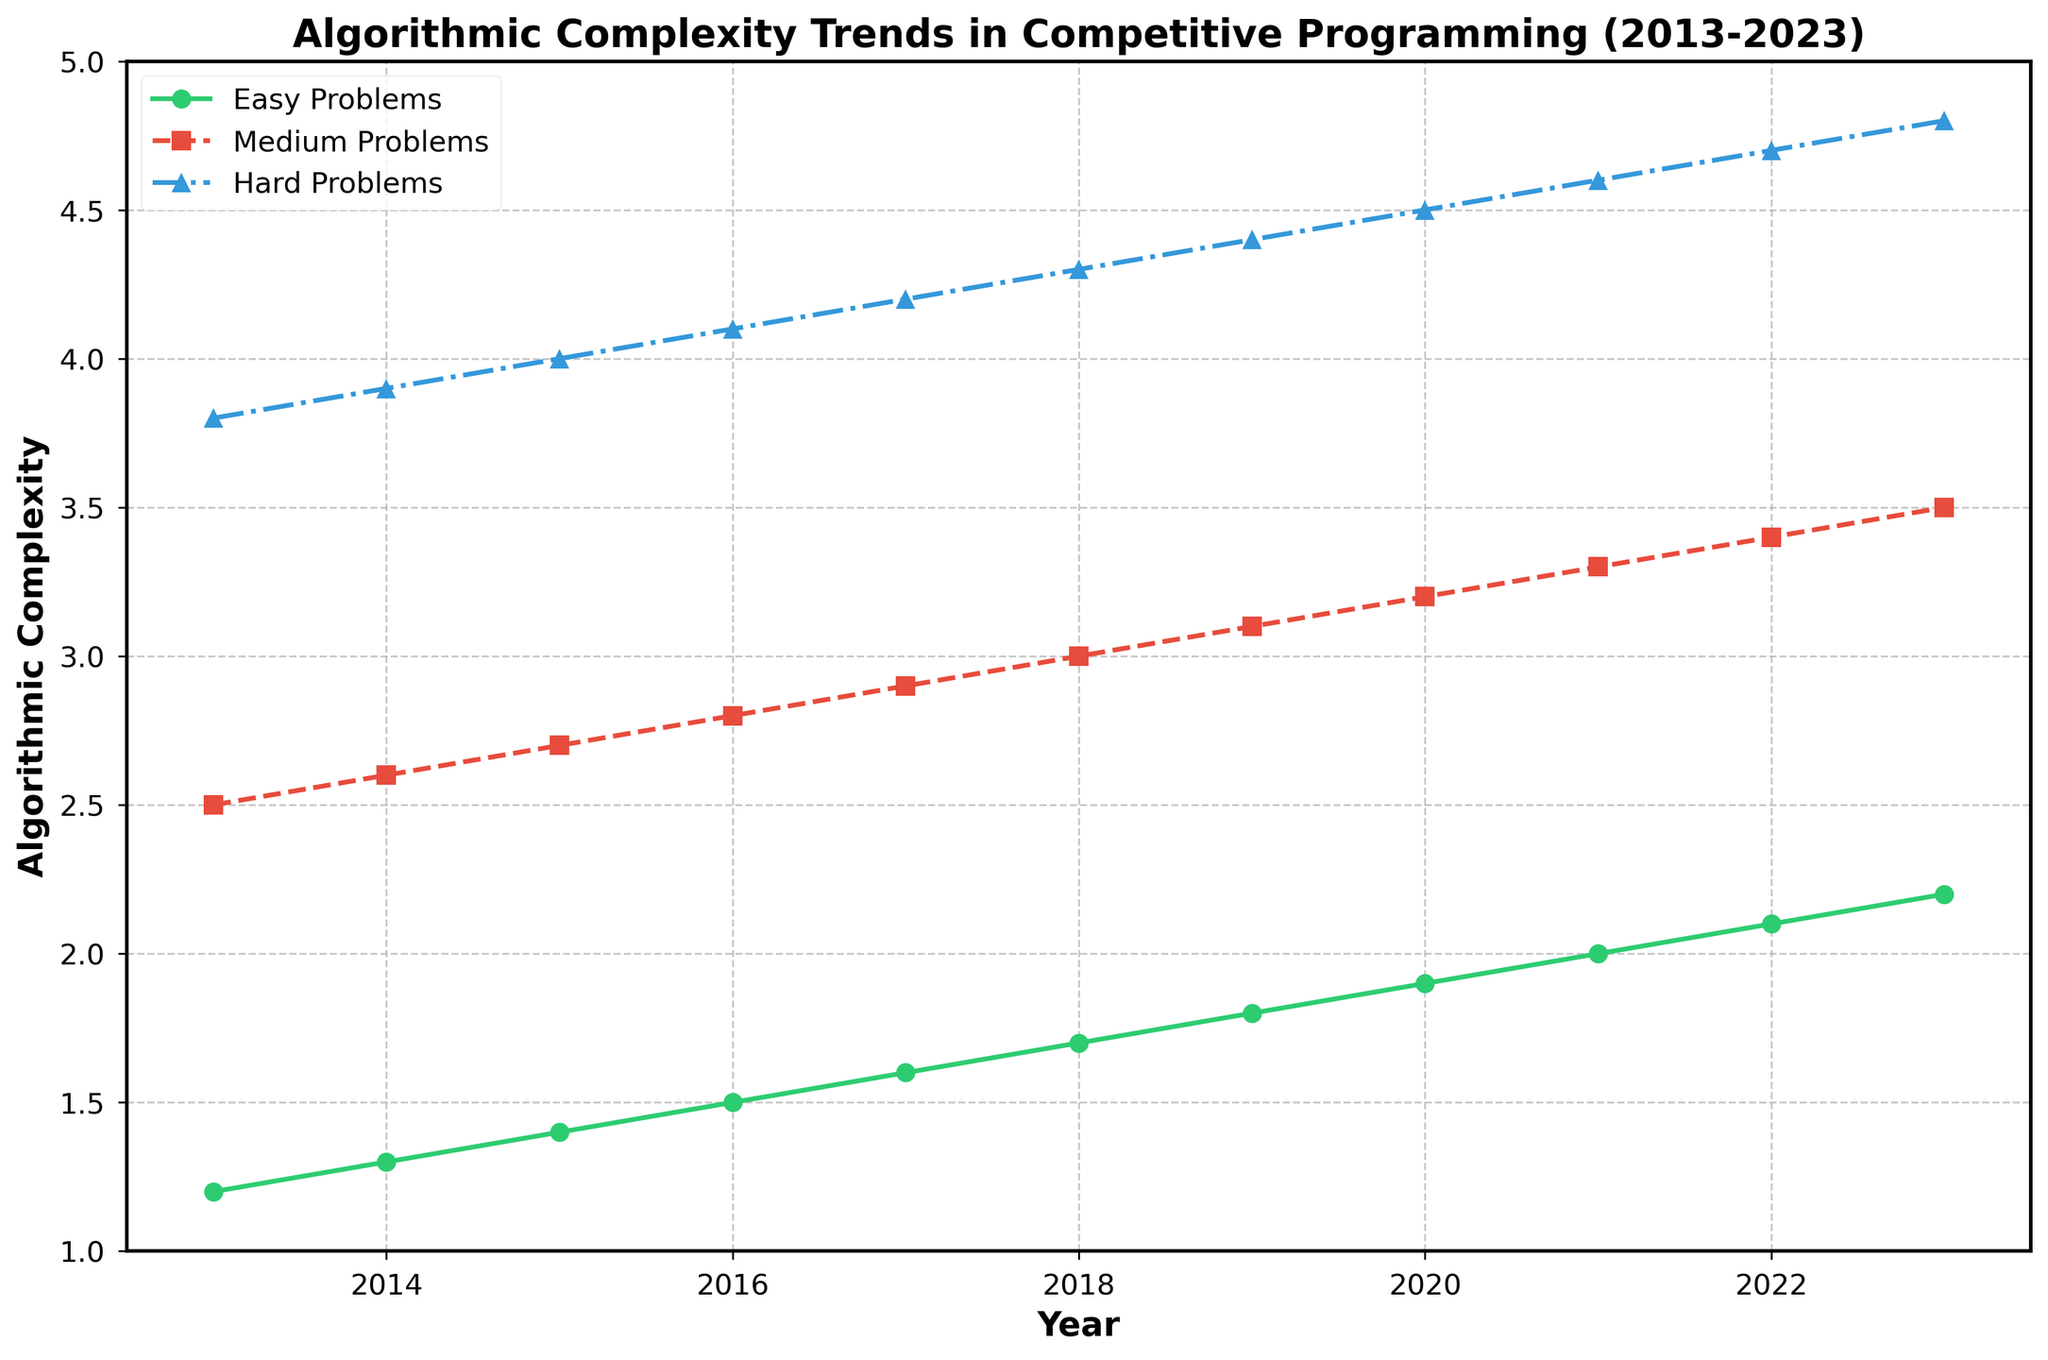What year did the algorithmic complexity for Easy Problems reach 2.0? According to the chart, the algorithmic complexity for Easy Problems reached 2.0 in the year where the green line crosses the 2.0 mark on the y-axis. This occurred in 2021.
Answer: 2021 During which year did the algorithmic complexity for Hard Problems surpass 4.0? The blue line representing Hard Problems surpasses the 4.0 mark on the y-axis when it crosses above this value. This first occurs between 2016 and 2017, specifically in 2017.
Answer: 2017 How much did the algorithmic complexity of Medium Problems increase from 2013 to 2023? From the chart, the complexity for Medium Problems (depicted by the red line) in 2013 is 2.5, and in 2023 it's 3.5. The increase is calculated as 3.5 - 2.5 = 1.0.
Answer: 1.0 Which category of problems showed the most significant increase in algorithmic complexity over the decade? To determine this, compare the increase for each category from 2013 to 2023. Easy Problems increased from 1.2 to 2.2 (1.0 increase), Medium Problems from 2.5 to 3.5 (1.0 increase), and Hard Problems from 3.8 to 4.8 (1.0 increase). All categories showed equal increases of 1.0.
Answer: Equal increase for all How does the rate of increase in algorithmic complexity for Easy Problems compare to Medium Problems between 2016 and 2020? Calculate the rate of increase for each by dividing the increase by the number of years. For Easy Problems: (1.9 - 1.5) / (2020 - 2016) = 0.4 / 4 = 0.1 per year. For Medium Problems: (3.2 - 2.8) / (2020 - 2016) = 0.4 / 4 = 0.1 per year. The rate is the same for both.
Answer: Same rate What was the algorithmic complexity of Hard Problems in 2023, and how much did it differ from Medium Problems in the same year? In 2023, the complexity for Hard Problems is 4.8, and for Medium Problems, it is 3.5. The difference is 4.8 - 3.5 = 1.3.
Answer: 1.3 Which category of problems had the smallest increase in algorithmic complexity from 2018 to 2020? Calculate the increases for each category from 2018 to 2020. Easy Problems: 1.9 - 1.7 = 0.2, Medium Problems: 3.2 - 3.0 = 0.2, and Hard Problems: 4.5 - 4.3 = 0.2. All categories had the same smallest increase of 0.2.
Answer: Equal increase for all At which point on the chart do all three problem categories have the same relative rate of increase? By examining each segment year-by-year, we see that the relative rate of increase is the same when the difference between the complexities for each problem category is consistent. This is observed where lines run in parallel. None; rates vary at different points.
Answer: None 